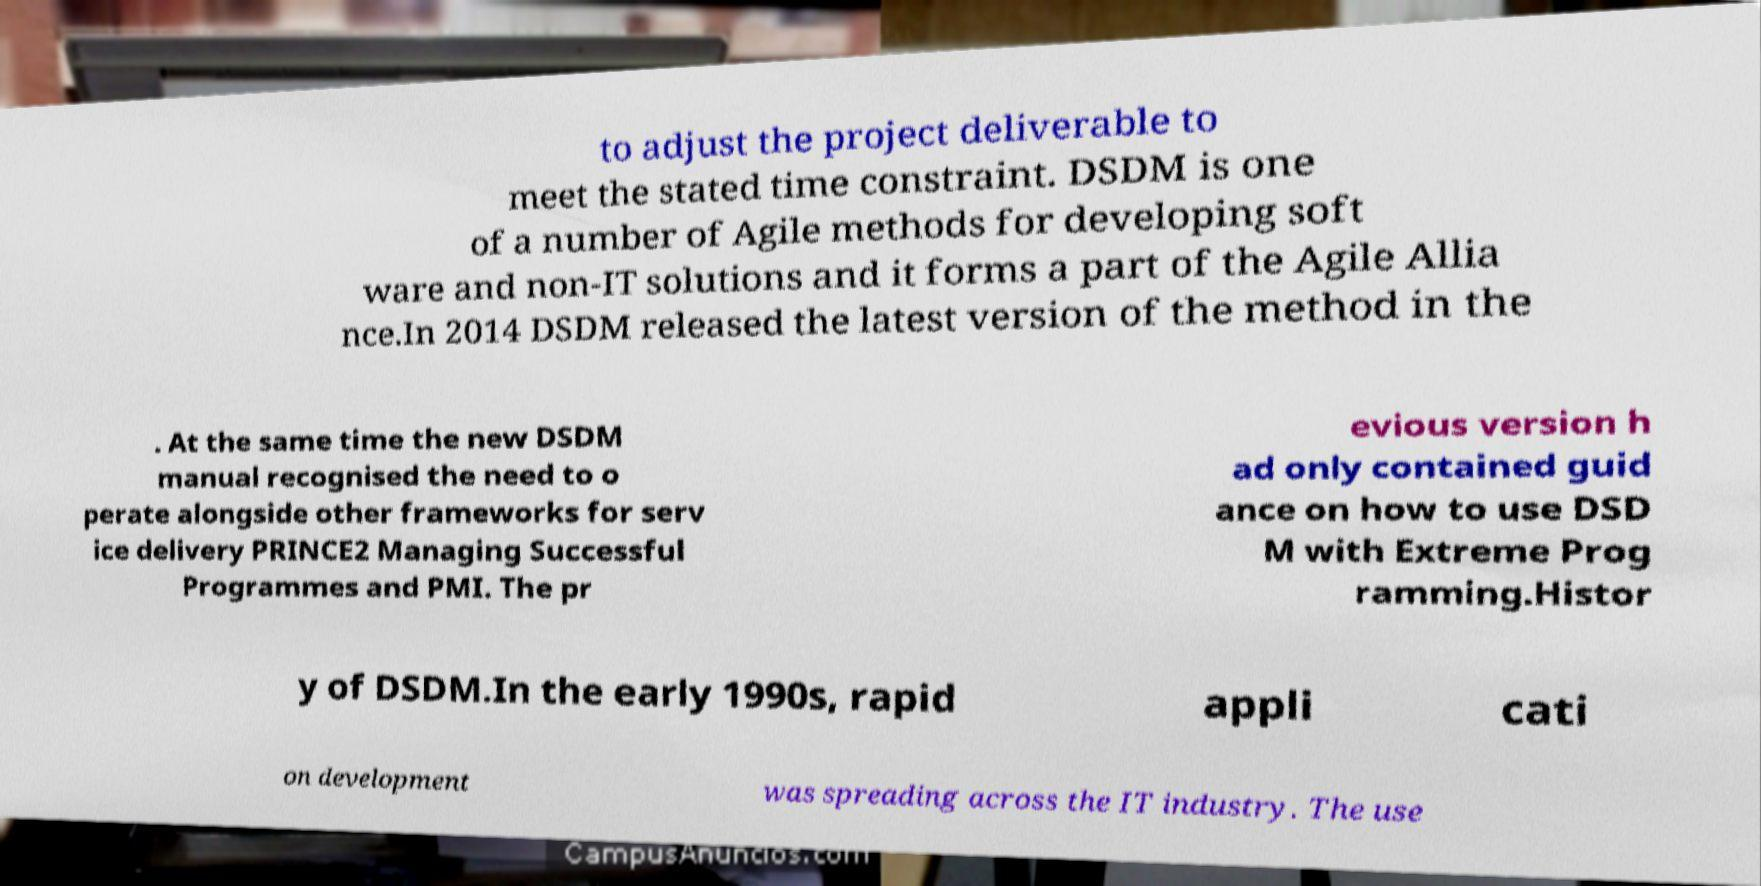I need the written content from this picture converted into text. Can you do that? to adjust the project deliverable to meet the stated time constraint. DSDM is one of a number of Agile methods for developing soft ware and non-IT solutions and it forms a part of the Agile Allia nce.In 2014 DSDM released the latest version of the method in the . At the same time the new DSDM manual recognised the need to o perate alongside other frameworks for serv ice delivery PRINCE2 Managing Successful Programmes and PMI. The pr evious version h ad only contained guid ance on how to use DSD M with Extreme Prog ramming.Histor y of DSDM.In the early 1990s, rapid appli cati on development was spreading across the IT industry. The use 